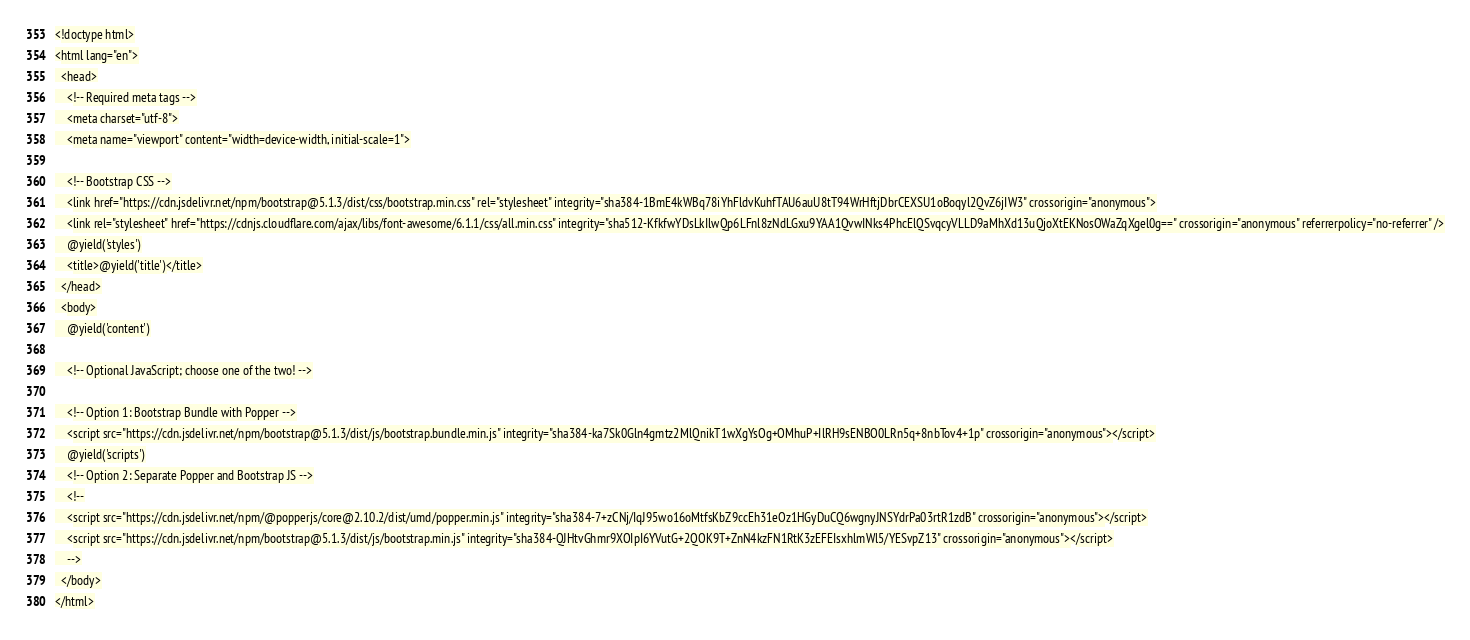Convert code to text. <code><loc_0><loc_0><loc_500><loc_500><_PHP_><!doctype html>
<html lang="en">
  <head>
    <!-- Required meta tags -->
    <meta charset="utf-8">
    <meta name="viewport" content="width=device-width, initial-scale=1">

    <!-- Bootstrap CSS -->
    <link href="https://cdn.jsdelivr.net/npm/bootstrap@5.1.3/dist/css/bootstrap.min.css" rel="stylesheet" integrity="sha384-1BmE4kWBq78iYhFldvKuhfTAU6auU8tT94WrHftjDbrCEXSU1oBoqyl2QvZ6jIW3" crossorigin="anonymous">
    <link rel="stylesheet" href="https://cdnjs.cloudflare.com/ajax/libs/font-awesome/6.1.1/css/all.min.css" integrity="sha512-KfkfwYDsLkIlwQp6LFnl8zNdLGxu9YAA1QvwINks4PhcElQSvqcyVLLD9aMhXd13uQjoXtEKNosOWaZqXgel0g==" crossorigin="anonymous" referrerpolicy="no-referrer" />
    @yield('styles')
    <title>@yield('title')</title>
  </head>
  <body>
    @yield('content')

    <!-- Optional JavaScript; choose one of the two! -->

    <!-- Option 1: Bootstrap Bundle with Popper -->
    <script src="https://cdn.jsdelivr.net/npm/bootstrap@5.1.3/dist/js/bootstrap.bundle.min.js" integrity="sha384-ka7Sk0Gln4gmtz2MlQnikT1wXgYsOg+OMhuP+IlRH9sENBO0LRn5q+8nbTov4+1p" crossorigin="anonymous"></script>
    @yield('scripts')
    <!-- Option 2: Separate Popper and Bootstrap JS -->
    <!--
    <script src="https://cdn.jsdelivr.net/npm/@popperjs/core@2.10.2/dist/umd/popper.min.js" integrity="sha384-7+zCNj/IqJ95wo16oMtfsKbZ9ccEh31eOz1HGyDuCQ6wgnyJNSYdrPa03rtR1zdB" crossorigin="anonymous"></script>
    <script src="https://cdn.jsdelivr.net/npm/bootstrap@5.1.3/dist/js/bootstrap.min.js" integrity="sha384-QJHtvGhmr9XOIpI6YVutG+2QOK9T+ZnN4kzFN1RtK3zEFEIsxhlmWl5/YESvpZ13" crossorigin="anonymous"></script>
    -->
  </body>
</html>
</code> 